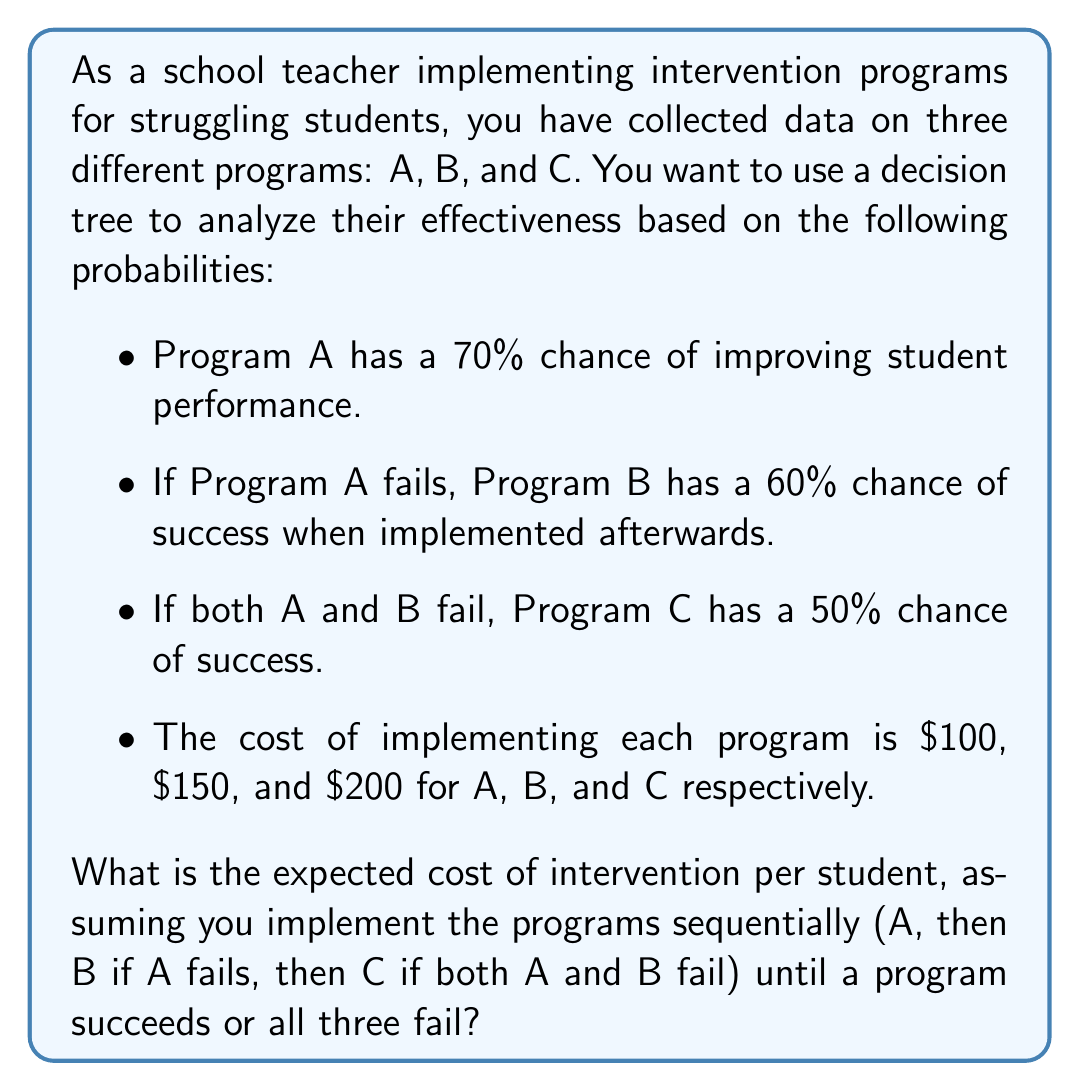Provide a solution to this math problem. Let's approach this problem step-by-step using a decision tree analysis:

1) First, let's calculate the probabilities of each outcome:

   P(A succeeds) = 0.7
   P(A fails, B succeeds) = 0.3 * 0.6 = 0.18
   P(A and B fail, C succeeds) = 0.3 * 0.4 * 0.5 = 0.06
   P(all fail) = 0.3 * 0.4 * 0.5 = 0.06

2) Now, let's calculate the cost for each outcome:

   If A succeeds: $100
   If A fails, B succeeds: $100 + $150 = $250
   If A and B fail, C succeeds: $100 + $150 + $200 = $450
   If all fail: $100 + $150 + $200 = $450

3) To calculate the expected cost, we multiply each outcome's probability by its cost and sum the results:

   E(Cost) = (0.7 * $100) + (0.18 * $250) + (0.06 * $450) + (0.06 * $450)

4) Let's compute this:

   E(Cost) = $70 + $45 + $27 + $27 = $169

Therefore, the expected cost of intervention per student is $169.

We can represent this decision tree mathematically as:

$$E(Cost) = P(A) \cdot C_A + P(B|A') \cdot (C_A + C_B) + P(C|A'B') \cdot (C_A + C_B + C_C) + P(A'B'C') \cdot (C_A + C_B + C_C)$$

Where:
$P(A)$ is the probability of A succeeding
$P(B|A')$ is the probability of B succeeding given A failed
$P(C|A'B')$ is the probability of C succeeding given A and B failed
$P(A'B'C')$ is the probability of all programs failing
$C_A$, $C_B$, and $C_C$ are the costs of programs A, B, and C respectively
Answer: $169 